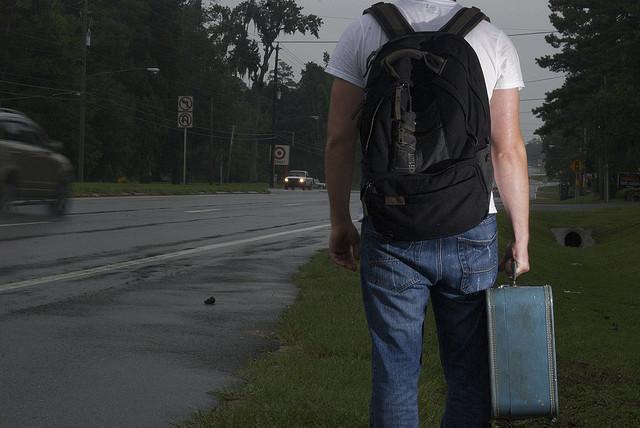How many backpacks are there?
Give a very brief answer. 1. 